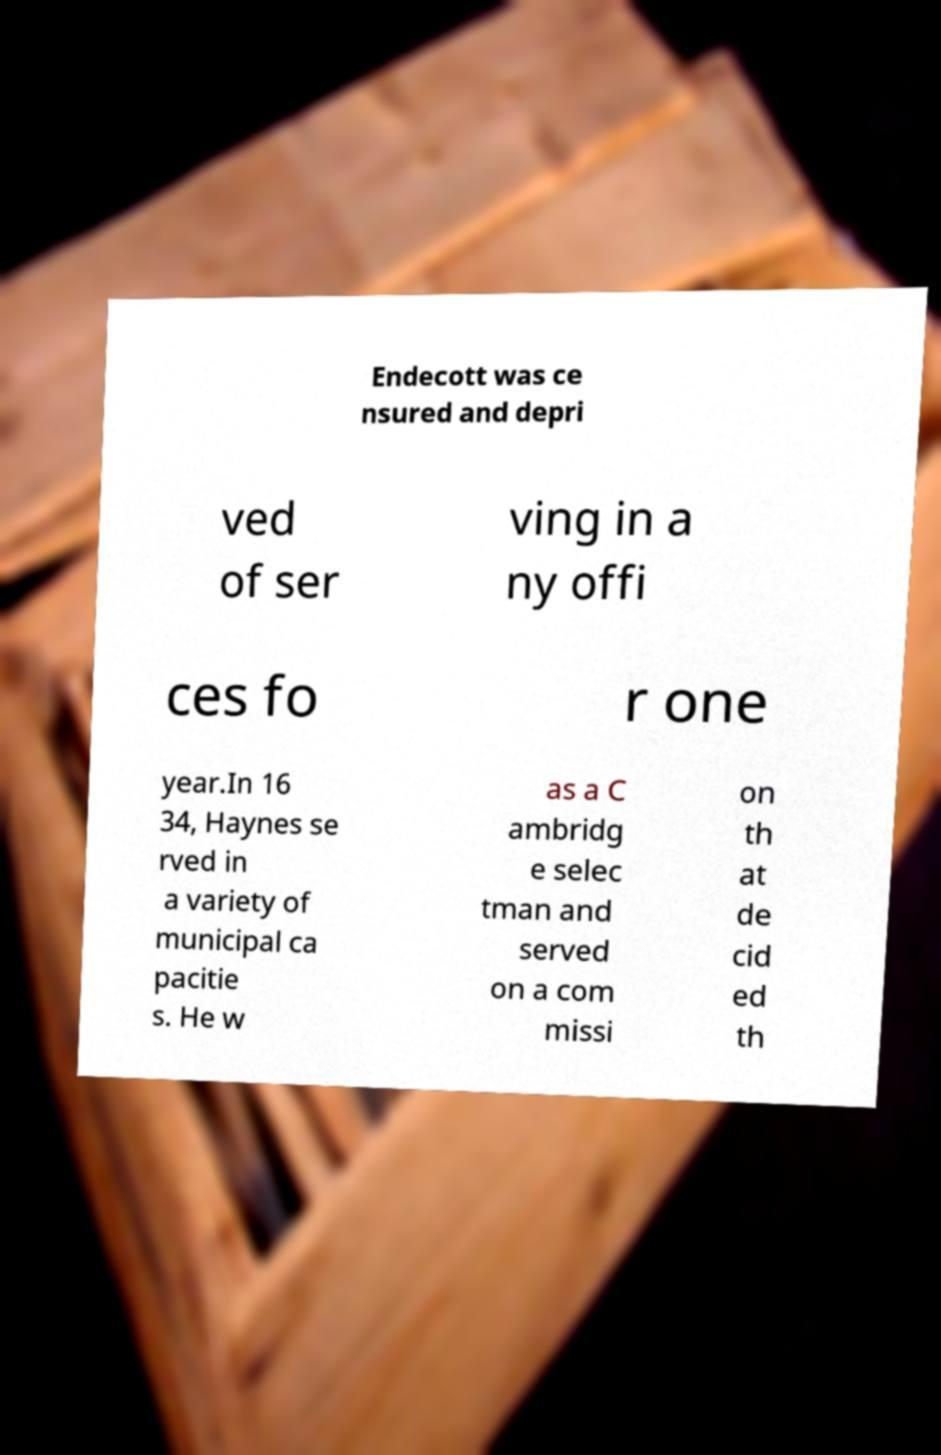What messages or text are displayed in this image? I need them in a readable, typed format. Endecott was ce nsured and depri ved of ser ving in a ny offi ces fo r one year.In 16 34, Haynes se rved in a variety of municipal ca pacitie s. He w as a C ambridg e selec tman and served on a com missi on th at de cid ed th 